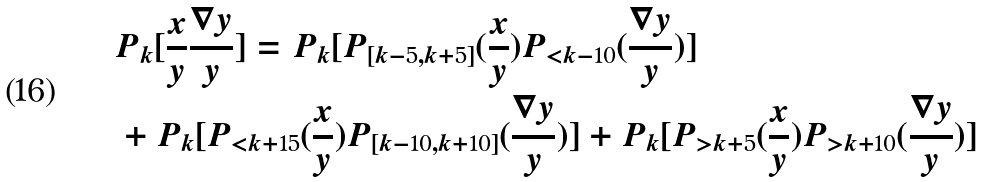Convert formula to latex. <formula><loc_0><loc_0><loc_500><loc_500>& P _ { k } [ \frac { x } { y } \frac { \nabla { y } } { y } ] = P _ { k } [ P _ { [ k - 5 , k + 5 ] } ( \frac { x } { y } ) P _ { < k - 1 0 } ( \frac { \nabla { y } } { y } ) ] \\ & + P _ { k } [ P _ { < k + 1 5 } ( \frac { x } { y } ) P _ { [ k - 1 0 , k + 1 0 ] } ( \frac { \nabla { y } } { y } ) ] + P _ { k } [ P _ { > k + 5 } ( \frac { x } { y } ) P _ { > k + 1 0 } ( \frac { \nabla { y } } { y } ) ] \\</formula> 